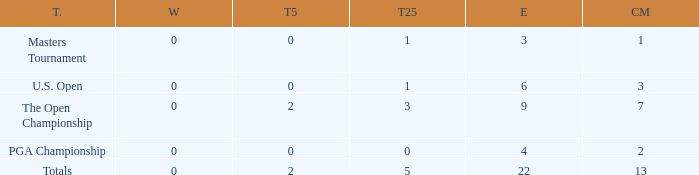How many total cuts were made in events with more than 0 wins and exactly 0 top-5s? 0.0. I'm looking to parse the entire table for insights. Could you assist me with that? {'header': ['T.', 'W', 'T5', 'T25', 'E', 'CM'], 'rows': [['Masters Tournament', '0', '0', '1', '3', '1'], ['U.S. Open', '0', '0', '1', '6', '3'], ['The Open Championship', '0', '2', '3', '9', '7'], ['PGA Championship', '0', '0', '0', '4', '2'], ['Totals', '0', '2', '5', '22', '13']]} 